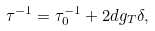Convert formula to latex. <formula><loc_0><loc_0><loc_500><loc_500>\tau ^ { - 1 } = \tau _ { 0 } ^ { - 1 } + 2 d g _ { T } \delta ,</formula> 